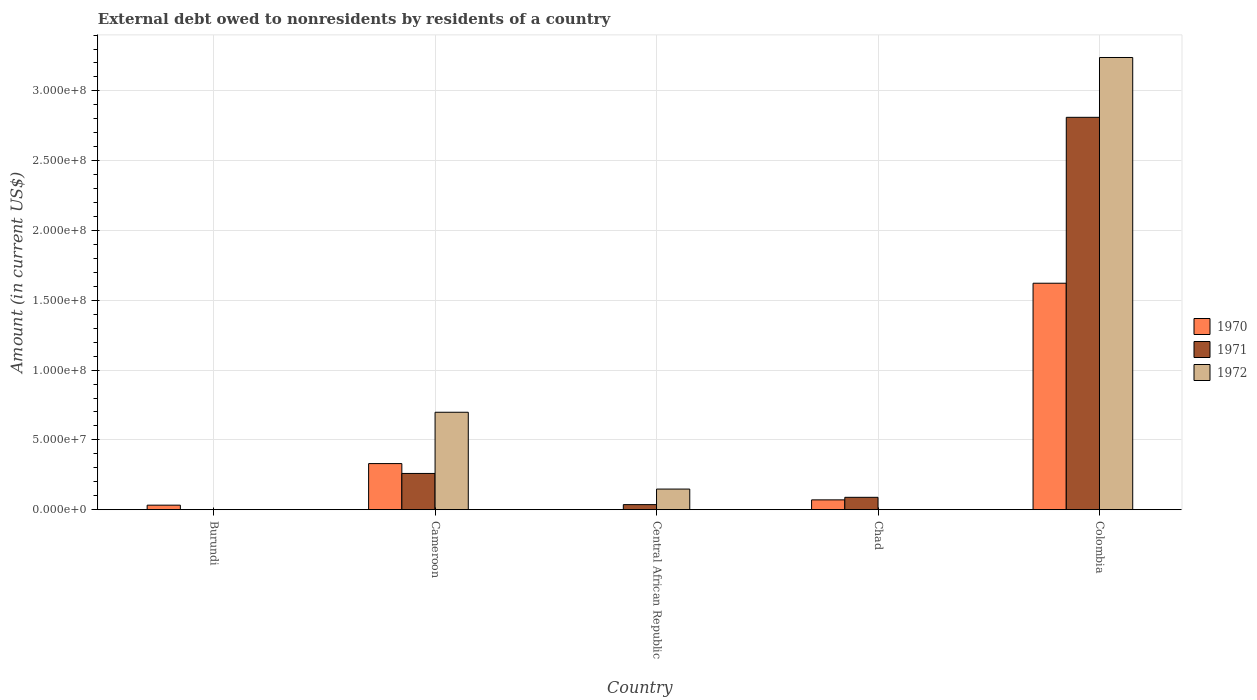How many different coloured bars are there?
Your response must be concise. 3. Are the number of bars on each tick of the X-axis equal?
Ensure brevity in your answer.  No. How many bars are there on the 3rd tick from the left?
Your response must be concise. 2. What is the label of the 5th group of bars from the left?
Offer a very short reply. Colombia. What is the external debt owed by residents in 1972 in Chad?
Give a very brief answer. 0. Across all countries, what is the maximum external debt owed by residents in 1971?
Offer a very short reply. 2.81e+08. Across all countries, what is the minimum external debt owed by residents in 1972?
Your response must be concise. 0. What is the total external debt owed by residents in 1972 in the graph?
Your answer should be very brief. 4.09e+08. What is the difference between the external debt owed by residents in 1970 in Chad and that in Colombia?
Provide a succinct answer. -1.55e+08. What is the difference between the external debt owed by residents in 1971 in Burundi and the external debt owed by residents in 1970 in Chad?
Make the answer very short. -7.04e+06. What is the average external debt owed by residents in 1970 per country?
Offer a very short reply. 4.11e+07. What is the difference between the external debt owed by residents of/in 1972 and external debt owed by residents of/in 1971 in Central African Republic?
Make the answer very short. 1.11e+07. What is the ratio of the external debt owed by residents in 1972 in Cameroon to that in Colombia?
Your answer should be very brief. 0.22. Is the external debt owed by residents in 1971 in Chad less than that in Colombia?
Ensure brevity in your answer.  Yes. Is the difference between the external debt owed by residents in 1972 in Central African Republic and Colombia greater than the difference between the external debt owed by residents in 1971 in Central African Republic and Colombia?
Ensure brevity in your answer.  No. What is the difference between the highest and the second highest external debt owed by residents in 1971?
Offer a very short reply. 2.72e+08. What is the difference between the highest and the lowest external debt owed by residents in 1970?
Your answer should be very brief. 1.62e+08. How many bars are there?
Keep it short and to the point. 11. What is the difference between two consecutive major ticks on the Y-axis?
Offer a terse response. 5.00e+07. Where does the legend appear in the graph?
Ensure brevity in your answer.  Center right. How many legend labels are there?
Offer a very short reply. 3. How are the legend labels stacked?
Provide a succinct answer. Vertical. What is the title of the graph?
Your response must be concise. External debt owed to nonresidents by residents of a country. Does "1995" appear as one of the legend labels in the graph?
Make the answer very short. No. What is the label or title of the Y-axis?
Keep it short and to the point. Amount (in current US$). What is the Amount (in current US$) in 1970 in Burundi?
Offer a very short reply. 3.25e+06. What is the Amount (in current US$) of 1970 in Cameroon?
Offer a very short reply. 3.30e+07. What is the Amount (in current US$) of 1971 in Cameroon?
Your response must be concise. 2.60e+07. What is the Amount (in current US$) of 1972 in Cameroon?
Make the answer very short. 6.98e+07. What is the Amount (in current US$) of 1971 in Central African Republic?
Keep it short and to the point. 3.64e+06. What is the Amount (in current US$) in 1972 in Central African Republic?
Offer a very short reply. 1.48e+07. What is the Amount (in current US$) of 1970 in Chad?
Your response must be concise. 7.04e+06. What is the Amount (in current US$) in 1971 in Chad?
Offer a very short reply. 8.87e+06. What is the Amount (in current US$) in 1970 in Colombia?
Provide a succinct answer. 1.62e+08. What is the Amount (in current US$) in 1971 in Colombia?
Make the answer very short. 2.81e+08. What is the Amount (in current US$) in 1972 in Colombia?
Give a very brief answer. 3.24e+08. Across all countries, what is the maximum Amount (in current US$) in 1970?
Ensure brevity in your answer.  1.62e+08. Across all countries, what is the maximum Amount (in current US$) in 1971?
Ensure brevity in your answer.  2.81e+08. Across all countries, what is the maximum Amount (in current US$) of 1972?
Offer a very short reply. 3.24e+08. Across all countries, what is the minimum Amount (in current US$) of 1971?
Keep it short and to the point. 0. Across all countries, what is the minimum Amount (in current US$) of 1972?
Your answer should be very brief. 0. What is the total Amount (in current US$) in 1970 in the graph?
Make the answer very short. 2.06e+08. What is the total Amount (in current US$) of 1971 in the graph?
Your response must be concise. 3.20e+08. What is the total Amount (in current US$) of 1972 in the graph?
Give a very brief answer. 4.09e+08. What is the difference between the Amount (in current US$) in 1970 in Burundi and that in Cameroon?
Give a very brief answer. -2.98e+07. What is the difference between the Amount (in current US$) in 1970 in Burundi and that in Chad?
Ensure brevity in your answer.  -3.80e+06. What is the difference between the Amount (in current US$) of 1970 in Burundi and that in Colombia?
Give a very brief answer. -1.59e+08. What is the difference between the Amount (in current US$) of 1971 in Cameroon and that in Central African Republic?
Provide a short and direct response. 2.23e+07. What is the difference between the Amount (in current US$) in 1972 in Cameroon and that in Central African Republic?
Provide a short and direct response. 5.50e+07. What is the difference between the Amount (in current US$) of 1970 in Cameroon and that in Chad?
Provide a succinct answer. 2.60e+07. What is the difference between the Amount (in current US$) of 1971 in Cameroon and that in Chad?
Provide a short and direct response. 1.71e+07. What is the difference between the Amount (in current US$) of 1970 in Cameroon and that in Colombia?
Make the answer very short. -1.29e+08. What is the difference between the Amount (in current US$) in 1971 in Cameroon and that in Colombia?
Give a very brief answer. -2.55e+08. What is the difference between the Amount (in current US$) in 1972 in Cameroon and that in Colombia?
Provide a short and direct response. -2.54e+08. What is the difference between the Amount (in current US$) of 1971 in Central African Republic and that in Chad?
Ensure brevity in your answer.  -5.22e+06. What is the difference between the Amount (in current US$) in 1971 in Central African Republic and that in Colombia?
Keep it short and to the point. -2.77e+08. What is the difference between the Amount (in current US$) in 1972 in Central African Republic and that in Colombia?
Your answer should be compact. -3.09e+08. What is the difference between the Amount (in current US$) in 1970 in Chad and that in Colombia?
Keep it short and to the point. -1.55e+08. What is the difference between the Amount (in current US$) of 1971 in Chad and that in Colombia?
Your response must be concise. -2.72e+08. What is the difference between the Amount (in current US$) of 1970 in Burundi and the Amount (in current US$) of 1971 in Cameroon?
Offer a very short reply. -2.27e+07. What is the difference between the Amount (in current US$) in 1970 in Burundi and the Amount (in current US$) in 1972 in Cameroon?
Keep it short and to the point. -6.66e+07. What is the difference between the Amount (in current US$) of 1970 in Burundi and the Amount (in current US$) of 1971 in Central African Republic?
Your answer should be compact. -3.96e+05. What is the difference between the Amount (in current US$) of 1970 in Burundi and the Amount (in current US$) of 1972 in Central African Republic?
Your response must be concise. -1.15e+07. What is the difference between the Amount (in current US$) of 1970 in Burundi and the Amount (in current US$) of 1971 in Chad?
Make the answer very short. -5.62e+06. What is the difference between the Amount (in current US$) of 1970 in Burundi and the Amount (in current US$) of 1971 in Colombia?
Provide a short and direct response. -2.78e+08. What is the difference between the Amount (in current US$) of 1970 in Burundi and the Amount (in current US$) of 1972 in Colombia?
Your answer should be very brief. -3.21e+08. What is the difference between the Amount (in current US$) of 1970 in Cameroon and the Amount (in current US$) of 1971 in Central African Republic?
Provide a short and direct response. 2.94e+07. What is the difference between the Amount (in current US$) in 1970 in Cameroon and the Amount (in current US$) in 1972 in Central African Republic?
Provide a succinct answer. 1.83e+07. What is the difference between the Amount (in current US$) of 1971 in Cameroon and the Amount (in current US$) of 1972 in Central African Republic?
Your response must be concise. 1.12e+07. What is the difference between the Amount (in current US$) of 1970 in Cameroon and the Amount (in current US$) of 1971 in Chad?
Provide a short and direct response. 2.42e+07. What is the difference between the Amount (in current US$) in 1970 in Cameroon and the Amount (in current US$) in 1971 in Colombia?
Provide a short and direct response. -2.48e+08. What is the difference between the Amount (in current US$) in 1970 in Cameroon and the Amount (in current US$) in 1972 in Colombia?
Your answer should be very brief. -2.91e+08. What is the difference between the Amount (in current US$) in 1971 in Cameroon and the Amount (in current US$) in 1972 in Colombia?
Offer a very short reply. -2.98e+08. What is the difference between the Amount (in current US$) in 1971 in Central African Republic and the Amount (in current US$) in 1972 in Colombia?
Keep it short and to the point. -3.20e+08. What is the difference between the Amount (in current US$) in 1970 in Chad and the Amount (in current US$) in 1971 in Colombia?
Give a very brief answer. -2.74e+08. What is the difference between the Amount (in current US$) of 1970 in Chad and the Amount (in current US$) of 1972 in Colombia?
Provide a succinct answer. -3.17e+08. What is the difference between the Amount (in current US$) in 1971 in Chad and the Amount (in current US$) in 1972 in Colombia?
Your answer should be very brief. -3.15e+08. What is the average Amount (in current US$) of 1970 per country?
Your answer should be very brief. 4.11e+07. What is the average Amount (in current US$) of 1971 per country?
Your response must be concise. 6.39e+07. What is the average Amount (in current US$) of 1972 per country?
Your answer should be compact. 8.17e+07. What is the difference between the Amount (in current US$) of 1970 and Amount (in current US$) of 1971 in Cameroon?
Your response must be concise. 7.06e+06. What is the difference between the Amount (in current US$) in 1970 and Amount (in current US$) in 1972 in Cameroon?
Keep it short and to the point. -3.68e+07. What is the difference between the Amount (in current US$) of 1971 and Amount (in current US$) of 1972 in Cameroon?
Keep it short and to the point. -4.38e+07. What is the difference between the Amount (in current US$) of 1971 and Amount (in current US$) of 1972 in Central African Republic?
Ensure brevity in your answer.  -1.11e+07. What is the difference between the Amount (in current US$) of 1970 and Amount (in current US$) of 1971 in Chad?
Offer a terse response. -1.82e+06. What is the difference between the Amount (in current US$) of 1970 and Amount (in current US$) of 1971 in Colombia?
Keep it short and to the point. -1.19e+08. What is the difference between the Amount (in current US$) of 1970 and Amount (in current US$) of 1972 in Colombia?
Provide a succinct answer. -1.62e+08. What is the difference between the Amount (in current US$) of 1971 and Amount (in current US$) of 1972 in Colombia?
Your answer should be compact. -4.29e+07. What is the ratio of the Amount (in current US$) in 1970 in Burundi to that in Cameroon?
Provide a succinct answer. 0.1. What is the ratio of the Amount (in current US$) in 1970 in Burundi to that in Chad?
Make the answer very short. 0.46. What is the ratio of the Amount (in current US$) in 1970 in Burundi to that in Colombia?
Your answer should be very brief. 0.02. What is the ratio of the Amount (in current US$) of 1971 in Cameroon to that in Central African Republic?
Give a very brief answer. 7.13. What is the ratio of the Amount (in current US$) of 1972 in Cameroon to that in Central African Republic?
Your answer should be very brief. 4.72. What is the ratio of the Amount (in current US$) of 1970 in Cameroon to that in Chad?
Give a very brief answer. 4.69. What is the ratio of the Amount (in current US$) in 1971 in Cameroon to that in Chad?
Provide a succinct answer. 2.93. What is the ratio of the Amount (in current US$) of 1970 in Cameroon to that in Colombia?
Your answer should be compact. 0.2. What is the ratio of the Amount (in current US$) in 1971 in Cameroon to that in Colombia?
Your answer should be compact. 0.09. What is the ratio of the Amount (in current US$) in 1972 in Cameroon to that in Colombia?
Your response must be concise. 0.22. What is the ratio of the Amount (in current US$) in 1971 in Central African Republic to that in Chad?
Offer a very short reply. 0.41. What is the ratio of the Amount (in current US$) in 1971 in Central African Republic to that in Colombia?
Offer a terse response. 0.01. What is the ratio of the Amount (in current US$) of 1972 in Central African Republic to that in Colombia?
Your response must be concise. 0.05. What is the ratio of the Amount (in current US$) of 1970 in Chad to that in Colombia?
Keep it short and to the point. 0.04. What is the ratio of the Amount (in current US$) in 1971 in Chad to that in Colombia?
Give a very brief answer. 0.03. What is the difference between the highest and the second highest Amount (in current US$) of 1970?
Offer a very short reply. 1.29e+08. What is the difference between the highest and the second highest Amount (in current US$) in 1971?
Give a very brief answer. 2.55e+08. What is the difference between the highest and the second highest Amount (in current US$) of 1972?
Your answer should be very brief. 2.54e+08. What is the difference between the highest and the lowest Amount (in current US$) of 1970?
Provide a short and direct response. 1.62e+08. What is the difference between the highest and the lowest Amount (in current US$) of 1971?
Provide a short and direct response. 2.81e+08. What is the difference between the highest and the lowest Amount (in current US$) in 1972?
Provide a short and direct response. 3.24e+08. 